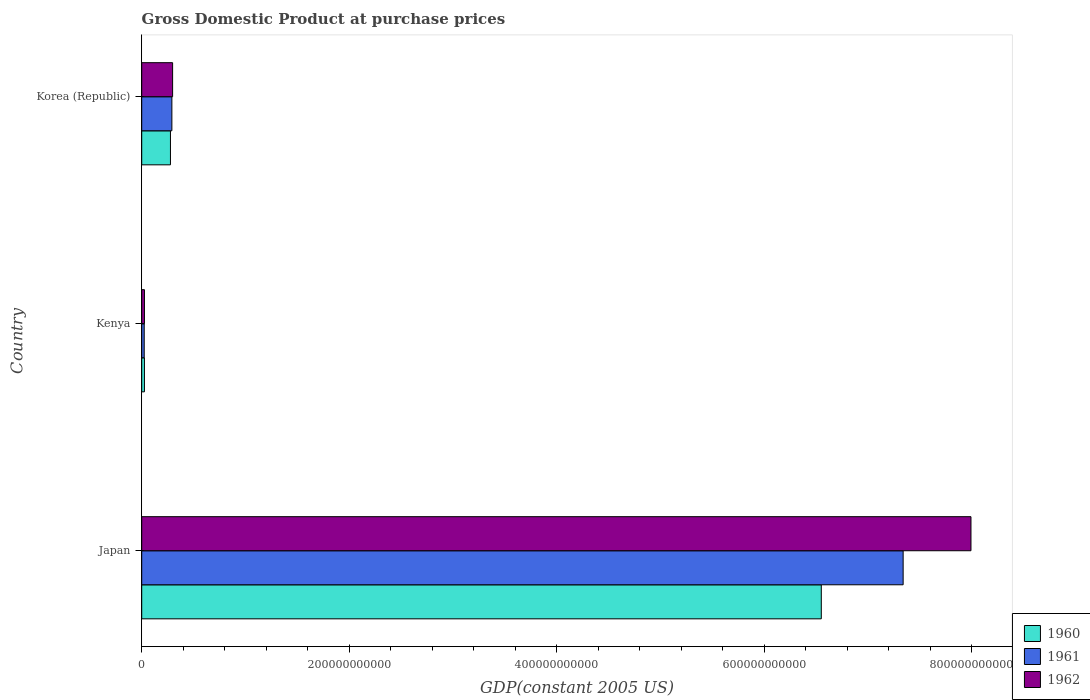How many groups of bars are there?
Your response must be concise. 3. What is the label of the 1st group of bars from the top?
Your answer should be compact. Korea (Republic). In how many cases, is the number of bars for a given country not equal to the number of legend labels?
Your response must be concise. 0. What is the GDP at purchase prices in 1960 in Korea (Republic)?
Offer a terse response. 2.77e+1. Across all countries, what is the maximum GDP at purchase prices in 1961?
Provide a short and direct response. 7.34e+11. Across all countries, what is the minimum GDP at purchase prices in 1961?
Make the answer very short. 2.41e+09. In which country was the GDP at purchase prices in 1962 minimum?
Provide a succinct answer. Kenya. What is the total GDP at purchase prices in 1962 in the graph?
Ensure brevity in your answer.  8.31e+11. What is the difference between the GDP at purchase prices in 1962 in Japan and that in Kenya?
Offer a terse response. 7.96e+11. What is the difference between the GDP at purchase prices in 1960 in Kenya and the GDP at purchase prices in 1961 in Korea (Republic)?
Your response must be concise. -2.64e+1. What is the average GDP at purchase prices in 1962 per country?
Your answer should be very brief. 2.77e+11. What is the difference between the GDP at purchase prices in 1961 and GDP at purchase prices in 1962 in Japan?
Provide a short and direct response. -6.54e+1. What is the ratio of the GDP at purchase prices in 1961 in Japan to that in Korea (Republic)?
Keep it short and to the point. 25.26. Is the difference between the GDP at purchase prices in 1961 in Japan and Kenya greater than the difference between the GDP at purchase prices in 1962 in Japan and Kenya?
Offer a terse response. No. What is the difference between the highest and the second highest GDP at purchase prices in 1961?
Ensure brevity in your answer.  7.05e+11. What is the difference between the highest and the lowest GDP at purchase prices in 1960?
Provide a succinct answer. 6.52e+11. In how many countries, is the GDP at purchase prices in 1962 greater than the average GDP at purchase prices in 1962 taken over all countries?
Offer a terse response. 1. Is it the case that in every country, the sum of the GDP at purchase prices in 1960 and GDP at purchase prices in 1962 is greater than the GDP at purchase prices in 1961?
Your response must be concise. Yes. What is the difference between two consecutive major ticks on the X-axis?
Offer a terse response. 2.00e+11. Are the values on the major ticks of X-axis written in scientific E-notation?
Provide a succinct answer. No. Does the graph contain any zero values?
Give a very brief answer. No. Does the graph contain grids?
Give a very brief answer. No. Where does the legend appear in the graph?
Your answer should be very brief. Bottom right. How are the legend labels stacked?
Ensure brevity in your answer.  Vertical. What is the title of the graph?
Offer a terse response. Gross Domestic Product at purchase prices. What is the label or title of the X-axis?
Your response must be concise. GDP(constant 2005 US). What is the label or title of the Y-axis?
Provide a succinct answer. Country. What is the GDP(constant 2005 US) of 1960 in Japan?
Give a very brief answer. 6.55e+11. What is the GDP(constant 2005 US) of 1961 in Japan?
Provide a succinct answer. 7.34e+11. What is the GDP(constant 2005 US) of 1962 in Japan?
Give a very brief answer. 7.99e+11. What is the GDP(constant 2005 US) in 1960 in Kenya?
Offer a terse response. 2.61e+09. What is the GDP(constant 2005 US) of 1961 in Kenya?
Your answer should be very brief. 2.41e+09. What is the GDP(constant 2005 US) of 1962 in Kenya?
Provide a succinct answer. 2.64e+09. What is the GDP(constant 2005 US) in 1960 in Korea (Republic)?
Offer a terse response. 2.77e+1. What is the GDP(constant 2005 US) in 1961 in Korea (Republic)?
Provide a succinct answer. 2.90e+1. What is the GDP(constant 2005 US) of 1962 in Korea (Republic)?
Your response must be concise. 2.98e+1. Across all countries, what is the maximum GDP(constant 2005 US) in 1960?
Your response must be concise. 6.55e+11. Across all countries, what is the maximum GDP(constant 2005 US) in 1961?
Keep it short and to the point. 7.34e+11. Across all countries, what is the maximum GDP(constant 2005 US) of 1962?
Give a very brief answer. 7.99e+11. Across all countries, what is the minimum GDP(constant 2005 US) of 1960?
Provide a succinct answer. 2.61e+09. Across all countries, what is the minimum GDP(constant 2005 US) of 1961?
Your answer should be very brief. 2.41e+09. Across all countries, what is the minimum GDP(constant 2005 US) of 1962?
Your answer should be compact. 2.64e+09. What is the total GDP(constant 2005 US) in 1960 in the graph?
Your answer should be compact. 6.85e+11. What is the total GDP(constant 2005 US) in 1961 in the graph?
Offer a very short reply. 7.65e+11. What is the total GDP(constant 2005 US) of 1962 in the graph?
Keep it short and to the point. 8.31e+11. What is the difference between the GDP(constant 2005 US) in 1960 in Japan and that in Kenya?
Provide a short and direct response. 6.52e+11. What is the difference between the GDP(constant 2005 US) in 1961 in Japan and that in Kenya?
Keep it short and to the point. 7.31e+11. What is the difference between the GDP(constant 2005 US) in 1962 in Japan and that in Kenya?
Ensure brevity in your answer.  7.96e+11. What is the difference between the GDP(constant 2005 US) of 1960 in Japan and that in Korea (Republic)?
Provide a succinct answer. 6.27e+11. What is the difference between the GDP(constant 2005 US) of 1961 in Japan and that in Korea (Republic)?
Ensure brevity in your answer.  7.05e+11. What is the difference between the GDP(constant 2005 US) in 1962 in Japan and that in Korea (Republic)?
Your response must be concise. 7.69e+11. What is the difference between the GDP(constant 2005 US) in 1960 in Kenya and that in Korea (Republic)?
Your answer should be very brief. -2.51e+1. What is the difference between the GDP(constant 2005 US) of 1961 in Kenya and that in Korea (Republic)?
Your answer should be compact. -2.66e+1. What is the difference between the GDP(constant 2005 US) of 1962 in Kenya and that in Korea (Republic)?
Provide a succinct answer. -2.71e+1. What is the difference between the GDP(constant 2005 US) in 1960 in Japan and the GDP(constant 2005 US) in 1961 in Kenya?
Make the answer very short. 6.52e+11. What is the difference between the GDP(constant 2005 US) of 1960 in Japan and the GDP(constant 2005 US) of 1962 in Kenya?
Your answer should be very brief. 6.52e+11. What is the difference between the GDP(constant 2005 US) of 1961 in Japan and the GDP(constant 2005 US) of 1962 in Kenya?
Make the answer very short. 7.31e+11. What is the difference between the GDP(constant 2005 US) of 1960 in Japan and the GDP(constant 2005 US) of 1961 in Korea (Republic)?
Provide a short and direct response. 6.26e+11. What is the difference between the GDP(constant 2005 US) in 1960 in Japan and the GDP(constant 2005 US) in 1962 in Korea (Republic)?
Make the answer very short. 6.25e+11. What is the difference between the GDP(constant 2005 US) in 1961 in Japan and the GDP(constant 2005 US) in 1962 in Korea (Republic)?
Give a very brief answer. 7.04e+11. What is the difference between the GDP(constant 2005 US) in 1960 in Kenya and the GDP(constant 2005 US) in 1961 in Korea (Republic)?
Provide a succinct answer. -2.64e+1. What is the difference between the GDP(constant 2005 US) of 1960 in Kenya and the GDP(constant 2005 US) of 1962 in Korea (Republic)?
Make the answer very short. -2.72e+1. What is the difference between the GDP(constant 2005 US) of 1961 in Kenya and the GDP(constant 2005 US) of 1962 in Korea (Republic)?
Keep it short and to the point. -2.74e+1. What is the average GDP(constant 2005 US) of 1960 per country?
Ensure brevity in your answer.  2.28e+11. What is the average GDP(constant 2005 US) of 1961 per country?
Your answer should be compact. 2.55e+11. What is the average GDP(constant 2005 US) in 1962 per country?
Ensure brevity in your answer.  2.77e+11. What is the difference between the GDP(constant 2005 US) of 1960 and GDP(constant 2005 US) of 1961 in Japan?
Your response must be concise. -7.89e+1. What is the difference between the GDP(constant 2005 US) of 1960 and GDP(constant 2005 US) of 1962 in Japan?
Provide a succinct answer. -1.44e+11. What is the difference between the GDP(constant 2005 US) in 1961 and GDP(constant 2005 US) in 1962 in Japan?
Offer a very short reply. -6.54e+1. What is the difference between the GDP(constant 2005 US) of 1960 and GDP(constant 2005 US) of 1961 in Kenya?
Give a very brief answer. 2.03e+08. What is the difference between the GDP(constant 2005 US) in 1960 and GDP(constant 2005 US) in 1962 in Kenya?
Offer a terse response. -2.47e+07. What is the difference between the GDP(constant 2005 US) of 1961 and GDP(constant 2005 US) of 1962 in Kenya?
Make the answer very short. -2.28e+08. What is the difference between the GDP(constant 2005 US) in 1960 and GDP(constant 2005 US) in 1961 in Korea (Republic)?
Your response must be concise. -1.37e+09. What is the difference between the GDP(constant 2005 US) in 1960 and GDP(constant 2005 US) in 1962 in Korea (Republic)?
Provide a succinct answer. -2.08e+09. What is the difference between the GDP(constant 2005 US) of 1961 and GDP(constant 2005 US) of 1962 in Korea (Republic)?
Make the answer very short. -7.14e+08. What is the ratio of the GDP(constant 2005 US) of 1960 in Japan to that in Kenya?
Your response must be concise. 250.83. What is the ratio of the GDP(constant 2005 US) in 1961 in Japan to that in Kenya?
Your answer should be very brief. 304.72. What is the ratio of the GDP(constant 2005 US) of 1962 in Japan to that in Kenya?
Your response must be concise. 303.2. What is the ratio of the GDP(constant 2005 US) of 1960 in Japan to that in Korea (Republic)?
Ensure brevity in your answer.  23.66. What is the ratio of the GDP(constant 2005 US) of 1961 in Japan to that in Korea (Republic)?
Offer a very short reply. 25.26. What is the ratio of the GDP(constant 2005 US) of 1962 in Japan to that in Korea (Republic)?
Your answer should be very brief. 26.85. What is the ratio of the GDP(constant 2005 US) in 1960 in Kenya to that in Korea (Republic)?
Offer a very short reply. 0.09. What is the ratio of the GDP(constant 2005 US) in 1961 in Kenya to that in Korea (Republic)?
Offer a very short reply. 0.08. What is the ratio of the GDP(constant 2005 US) in 1962 in Kenya to that in Korea (Republic)?
Provide a succinct answer. 0.09. What is the difference between the highest and the second highest GDP(constant 2005 US) of 1960?
Ensure brevity in your answer.  6.27e+11. What is the difference between the highest and the second highest GDP(constant 2005 US) in 1961?
Your answer should be compact. 7.05e+11. What is the difference between the highest and the second highest GDP(constant 2005 US) in 1962?
Provide a short and direct response. 7.69e+11. What is the difference between the highest and the lowest GDP(constant 2005 US) in 1960?
Provide a short and direct response. 6.52e+11. What is the difference between the highest and the lowest GDP(constant 2005 US) in 1961?
Offer a very short reply. 7.31e+11. What is the difference between the highest and the lowest GDP(constant 2005 US) of 1962?
Ensure brevity in your answer.  7.96e+11. 